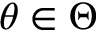<formula> <loc_0><loc_0><loc_500><loc_500>\theta \in \Theta</formula> 